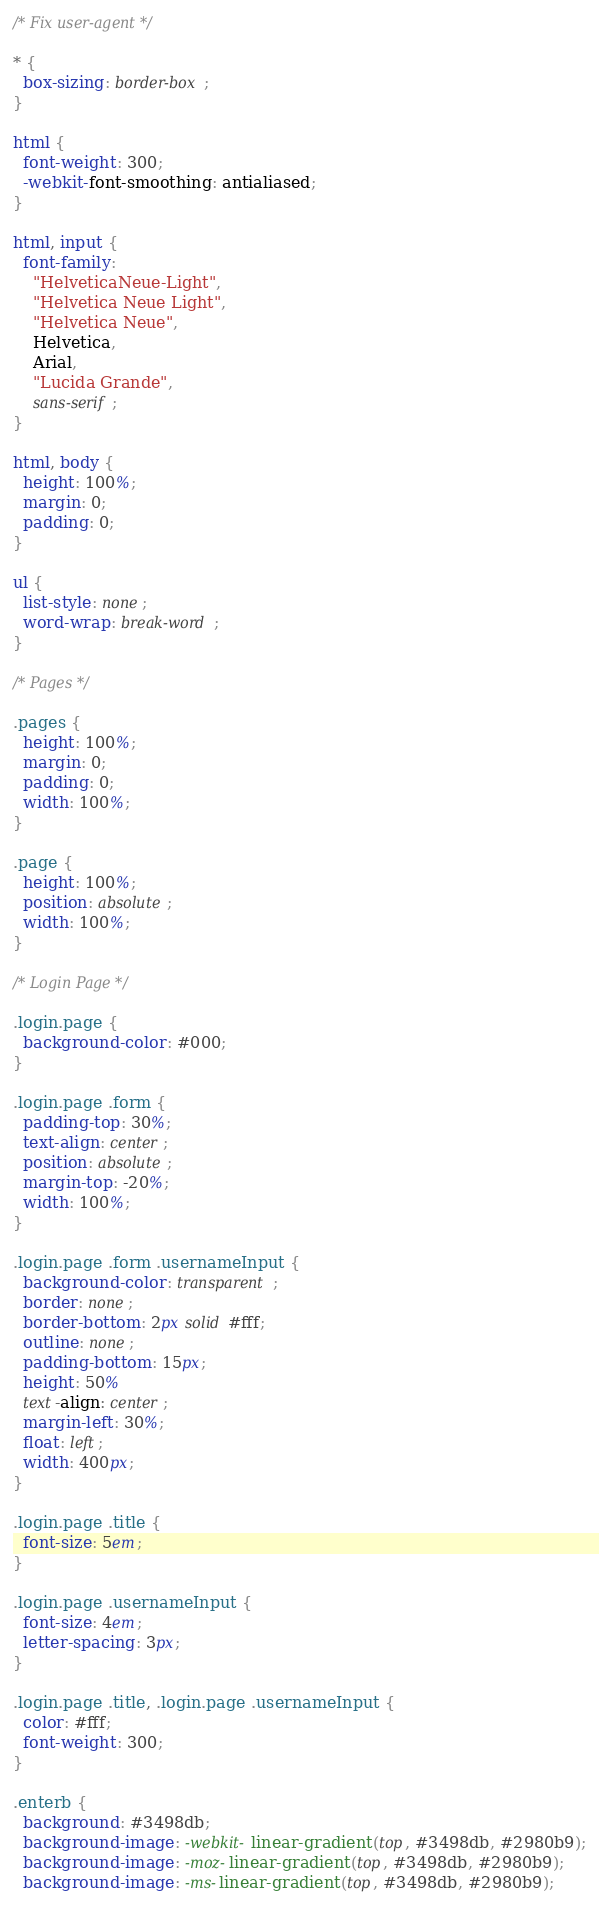<code> <loc_0><loc_0><loc_500><loc_500><_CSS_>/* Fix user-agent */

* {
  box-sizing: border-box;
}

html {
  font-weight: 300;
  -webkit-font-smoothing: antialiased;
}

html, input {
  font-family:
    "HelveticaNeue-Light",
    "Helvetica Neue Light",
    "Helvetica Neue",
    Helvetica,
    Arial,
    "Lucida Grande",
    sans-serif;
}

html, body {
  height: 100%;
  margin: 0;
  padding: 0;
}

ul {
  list-style: none;
  word-wrap: break-word;
}

/* Pages */

.pages {
  height: 100%;
  margin: 0;
  padding: 0;
  width: 100%;
}

.page {
  height: 100%;
  position: absolute;
  width: 100%;
}

/* Login Page */

.login.page {
  background-color: #000;
}

.login.page .form {
  padding-top: 30%;
  text-align: center;
  position: absolute;
  margin-top: -20%;
  width: 100%;
}

.login.page .form .usernameInput {
  background-color: transparent;
  border: none;
  border-bottom: 2px solid #fff;
  outline: none;
  padding-bottom: 15px;
  height: 50%
  text-align: center;
  margin-left: 30%;
  float: left;
  width: 400px;
}

.login.page .title {
  font-size: 5em;
}

.login.page .usernameInput {
  font-size: 4em;
  letter-spacing: 3px;
}

.login.page .title, .login.page .usernameInput {
  color: #fff;
  font-weight: 300;
}

.enterb {
  background: #3498db;
  background-image: -webkit-linear-gradient(top, #3498db, #2980b9);
  background-image: -moz-linear-gradient(top, #3498db, #2980b9);
  background-image: -ms-linear-gradient(top, #3498db, #2980b9);</code> 